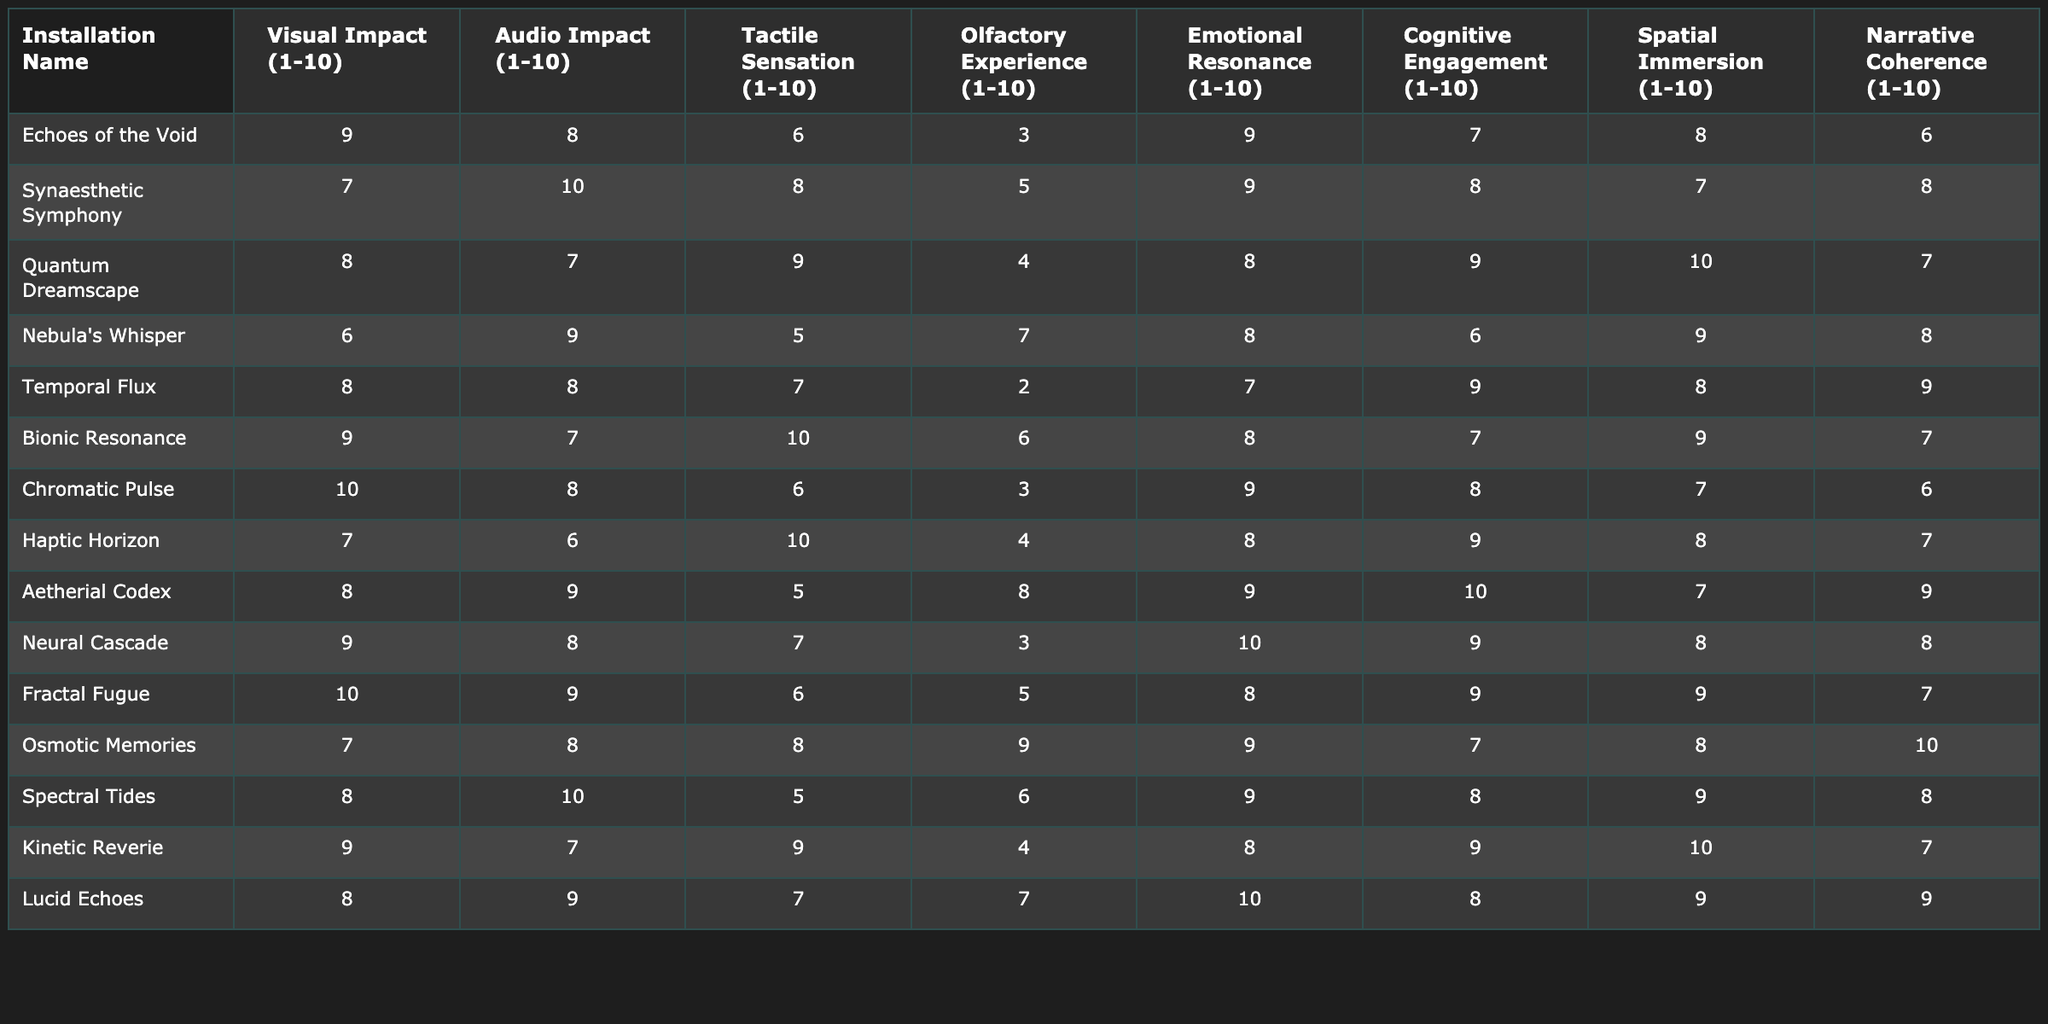What is the highest visual impact rating among the installations? The installation "Chromatic Pulse" has the highest visual impact rating of 10.
Answer: 10 What installation has the lowest olfactory experience rating? "Echoes of the Void" has the lowest olfactory experience rating of 3.
Answer: 3 Which installation scored the highest in emotional resonance? "Neural Cascade" and "Lucid Echoes" both scored the highest in emotional resonance with a score of 10.
Answer: 10 What is the average audio impact rating across all installations? Adding the audio impact ratings gives a total of 105. Dividing by the 14 installations results in an average of 7.5.
Answer: 7.5 How many installations received a spatial immersion score of 10? Only one installation, "Quantum Dreamscape," received a spatial immersion score of 10.
Answer: 1 Which installation shows the greatest discrepancy between visual impact and emotional resonance? Comparing "Chromatic Pulse" (visual impact 10, emotional resonance 9) and "Nebula's Whisper" (visual impact 6, emotional resonance 8), the greatest discrepancy is with "Chromatic Pulse" with 1 point difference.
Answer: Chromatic Pulse What installation has the best average rating across all sensory impact categories? By calculating the average ratings, "Aetherial Codex" (8.625) has the highest average across all sensory categories.
Answer: Aetherial Codex Is there any installation that scored a 10 in both visual and spatial immersion impacts? No installation received a score of 10 in both visual impact and spatial immersion; the highest scores are 10 for visual (Chromatic Pulse) and 10 for spatial (Quantum Dreamscape) but not together.
Answer: No Which installation has the lowest score in tactile sensation and what is that score? "Nebula's Whisper" has the lowest score in tactile sensation with a rating of 5.
Answer: 5 How does the audio impact of "Synaesthetic Symphony" compare to "Temporal Flux"? "Synaesthetic Symphony" scored 10 in audio impact while "Temporal Flux" scored 8; thus, "Synaesthetic Symphony" is higher by 2 points.
Answer: Synaesthetic Symphony is higher by 2 points Which installations have an emotional resonance rating higher than their cognitive engagement rating? "Echoes of the Void," "Synaesthetic Symphony," "Quantum Dreamscape," "Aetherial Codex," "Lucid Echoes," and "Osmotic Memories" have emotional resonance ratings higher than cognitive engagement ratings.
Answer: 6 installations 